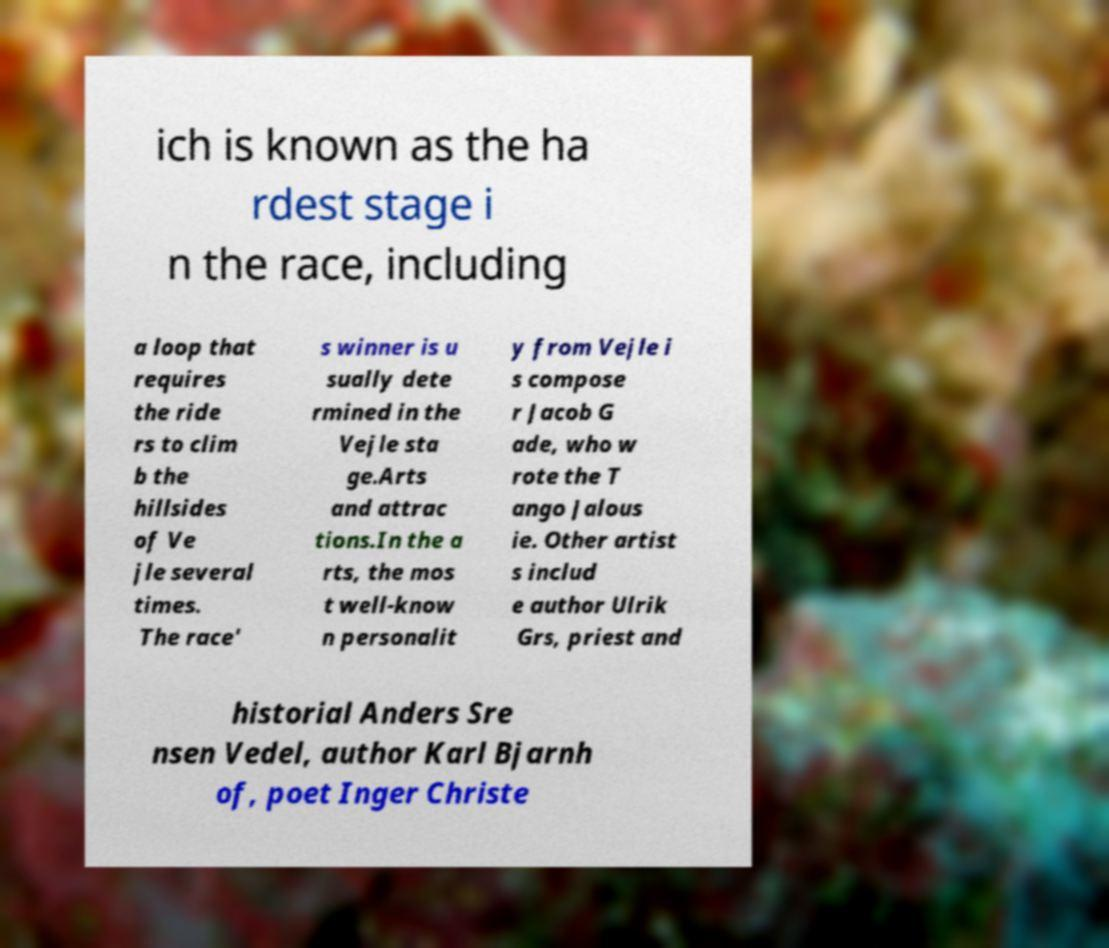Can you read and provide the text displayed in the image?This photo seems to have some interesting text. Can you extract and type it out for me? ich is known as the ha rdest stage i n the race, including a loop that requires the ride rs to clim b the hillsides of Ve jle several times. The race' s winner is u sually dete rmined in the Vejle sta ge.Arts and attrac tions.In the a rts, the mos t well-know n personalit y from Vejle i s compose r Jacob G ade, who w rote the T ango Jalous ie. Other artist s includ e author Ulrik Grs, priest and historial Anders Sre nsen Vedel, author Karl Bjarnh of, poet Inger Christe 